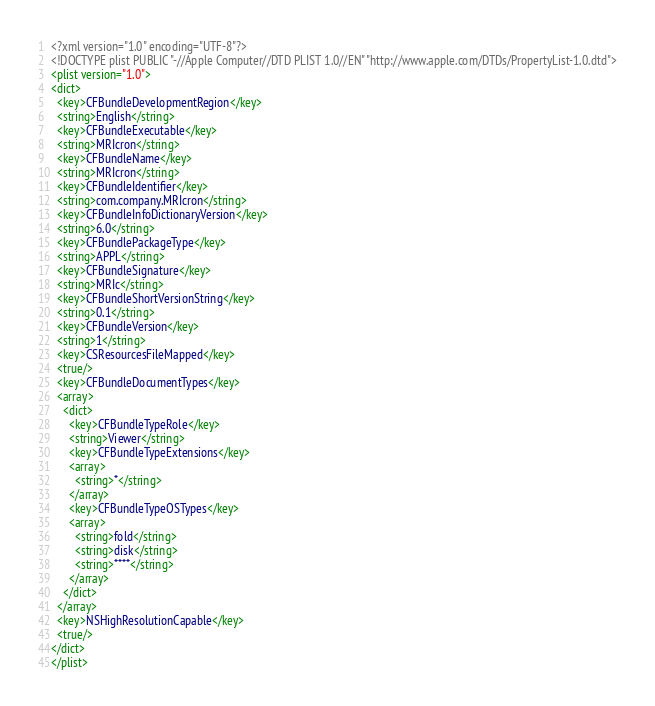Convert code to text. <code><loc_0><loc_0><loc_500><loc_500><_XML_><?xml version="1.0" encoding="UTF-8"?>
<!DOCTYPE plist PUBLIC "-//Apple Computer//DTD PLIST 1.0//EN" "http://www.apple.com/DTDs/PropertyList-1.0.dtd">
<plist version="1.0">
<dict>
  <key>CFBundleDevelopmentRegion</key>
  <string>English</string>
  <key>CFBundleExecutable</key>
  <string>MRIcron</string>
  <key>CFBundleName</key>
  <string>MRIcron</string>
  <key>CFBundleIdentifier</key>
  <string>com.company.MRIcron</string>
  <key>CFBundleInfoDictionaryVersion</key>
  <string>6.0</string>
  <key>CFBundlePackageType</key>
  <string>APPL</string>
  <key>CFBundleSignature</key>
  <string>MRIc</string>
  <key>CFBundleShortVersionString</key>
  <string>0.1</string>
  <key>CFBundleVersion</key>
  <string>1</string>
  <key>CSResourcesFileMapped</key>
  <true/>
  <key>CFBundleDocumentTypes</key>
  <array>
    <dict>
      <key>CFBundleTypeRole</key>
      <string>Viewer</string>
      <key>CFBundleTypeExtensions</key>
      <array>
        <string>*</string>
      </array>
      <key>CFBundleTypeOSTypes</key>
      <array>
        <string>fold</string>
        <string>disk</string>
        <string>****</string>
      </array>
    </dict>
  </array>
  <key>NSHighResolutionCapable</key>
  <true/>
</dict>
</plist>
</code> 